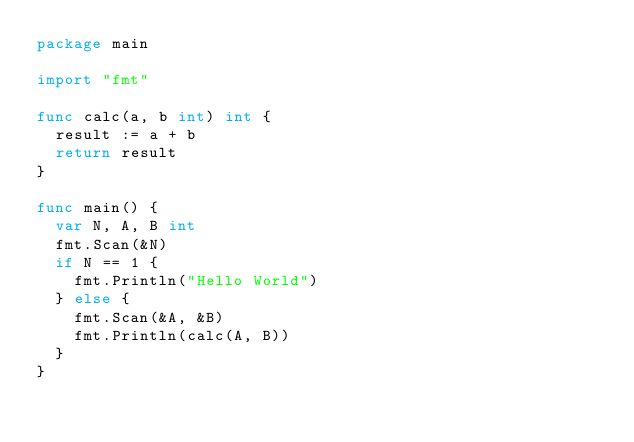Convert code to text. <code><loc_0><loc_0><loc_500><loc_500><_Go_>package main

import "fmt"

func calc(a, b int) int {
	result := a + b
	return result
}

func main() {
	var N, A, B int
	fmt.Scan(&N)
	if N == 1 {
		fmt.Println("Hello World")
	} else {
		fmt.Scan(&A, &B)
		fmt.Println(calc(A, B))
	}
}
</code> 